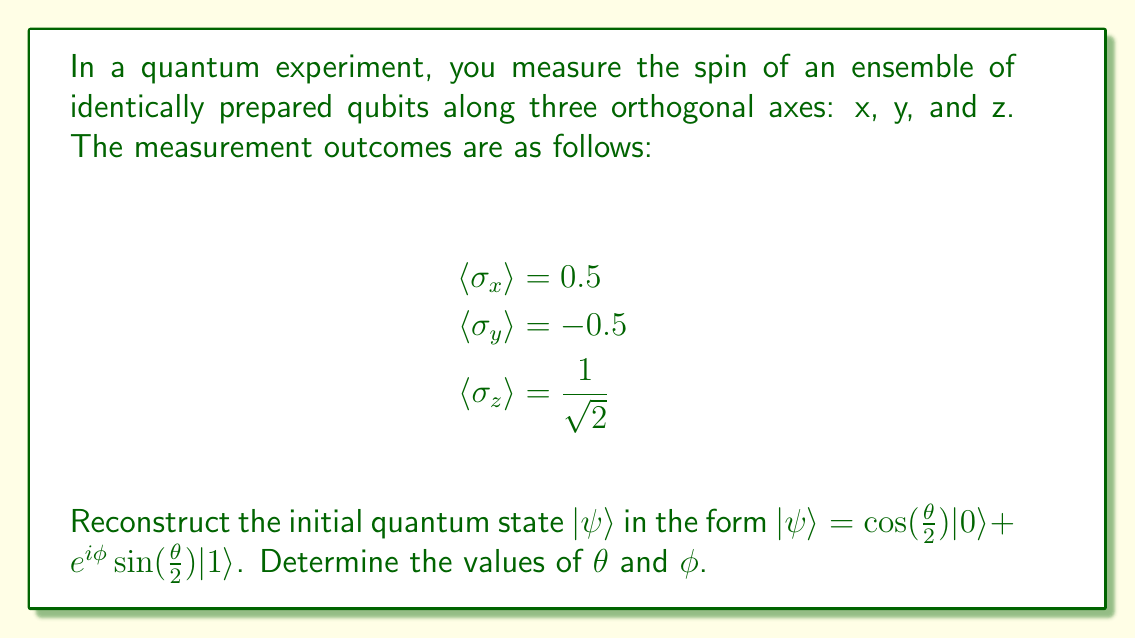Could you help me with this problem? To reconstruct the initial quantum state, we'll follow these steps:

1) The general form of a qubit state is:
   $|\psi\rangle = \cos(\frac{\theta}{2})|0\rangle + e^{i\phi}\sin(\frac{\theta}{2})|1\rangle$

2) The expectation values of the Pauli operators for this state are:
   $\langle \sigma_x \rangle = \sin\theta\cos\phi$
   $\langle \sigma_y \rangle = \sin\theta\sin\phi$
   $\langle \sigma_z \rangle = \cos\theta$

3) From the given measurements:
   $\sin\theta\cos\phi = 0.5$
   $\sin\theta\sin\phi = -0.5$
   $\cos\theta = \frac{1}{\sqrt{2}}$

4) From $\cos\theta = \frac{1}{\sqrt{2}}$, we can determine $\theta$:
   $\theta = \arccos(\frac{1}{\sqrt{2}}) = \frac{\pi}{4}$

5) Now, $\sin\theta = \frac{1}{\sqrt{2}}$

6) Using this, we can find $\cos\phi$ and $\sin\phi$:
   $\cos\phi = \frac{0.5}{\sin\theta} = \frac{0.5}{\frac{1}{\sqrt{2}}} = \frac{1}{\sqrt{2}}$
   $\sin\phi = \frac{-0.5}{\sin\theta} = \frac{-0.5}{\frac{1}{\sqrt{2}}} = -\frac{1}{\sqrt{2}}$

7) This corresponds to $\phi = -\frac{\pi}{4}$

Therefore, the reconstructed quantum state is:
$|\psi\rangle = \cos(\frac{\pi}{8})|0\rangle + e^{-i\frac{\pi}{4}}\sin(\frac{\pi}{8})|1\rangle$
Answer: $\theta = \frac{\pi}{4}$, $\phi = -\frac{\pi}{4}$ 